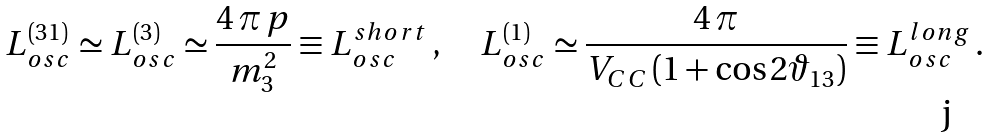Convert formula to latex. <formula><loc_0><loc_0><loc_500><loc_500>L _ { o s c } ^ { ( 3 1 ) } \simeq L _ { o s c } ^ { ( 3 ) } \simeq \frac { 4 \, \pi \, p } { m _ { 3 } ^ { 2 } } \equiv L _ { o s c } ^ { s h o r t } \, , \quad L _ { o s c } ^ { ( 1 ) } \simeq \frac { 4 \, \pi } { V _ { C C } \left ( 1 + \cos 2 \vartheta _ { 1 3 } \right ) } \equiv L _ { o s c } ^ { l o n g } \, .</formula> 